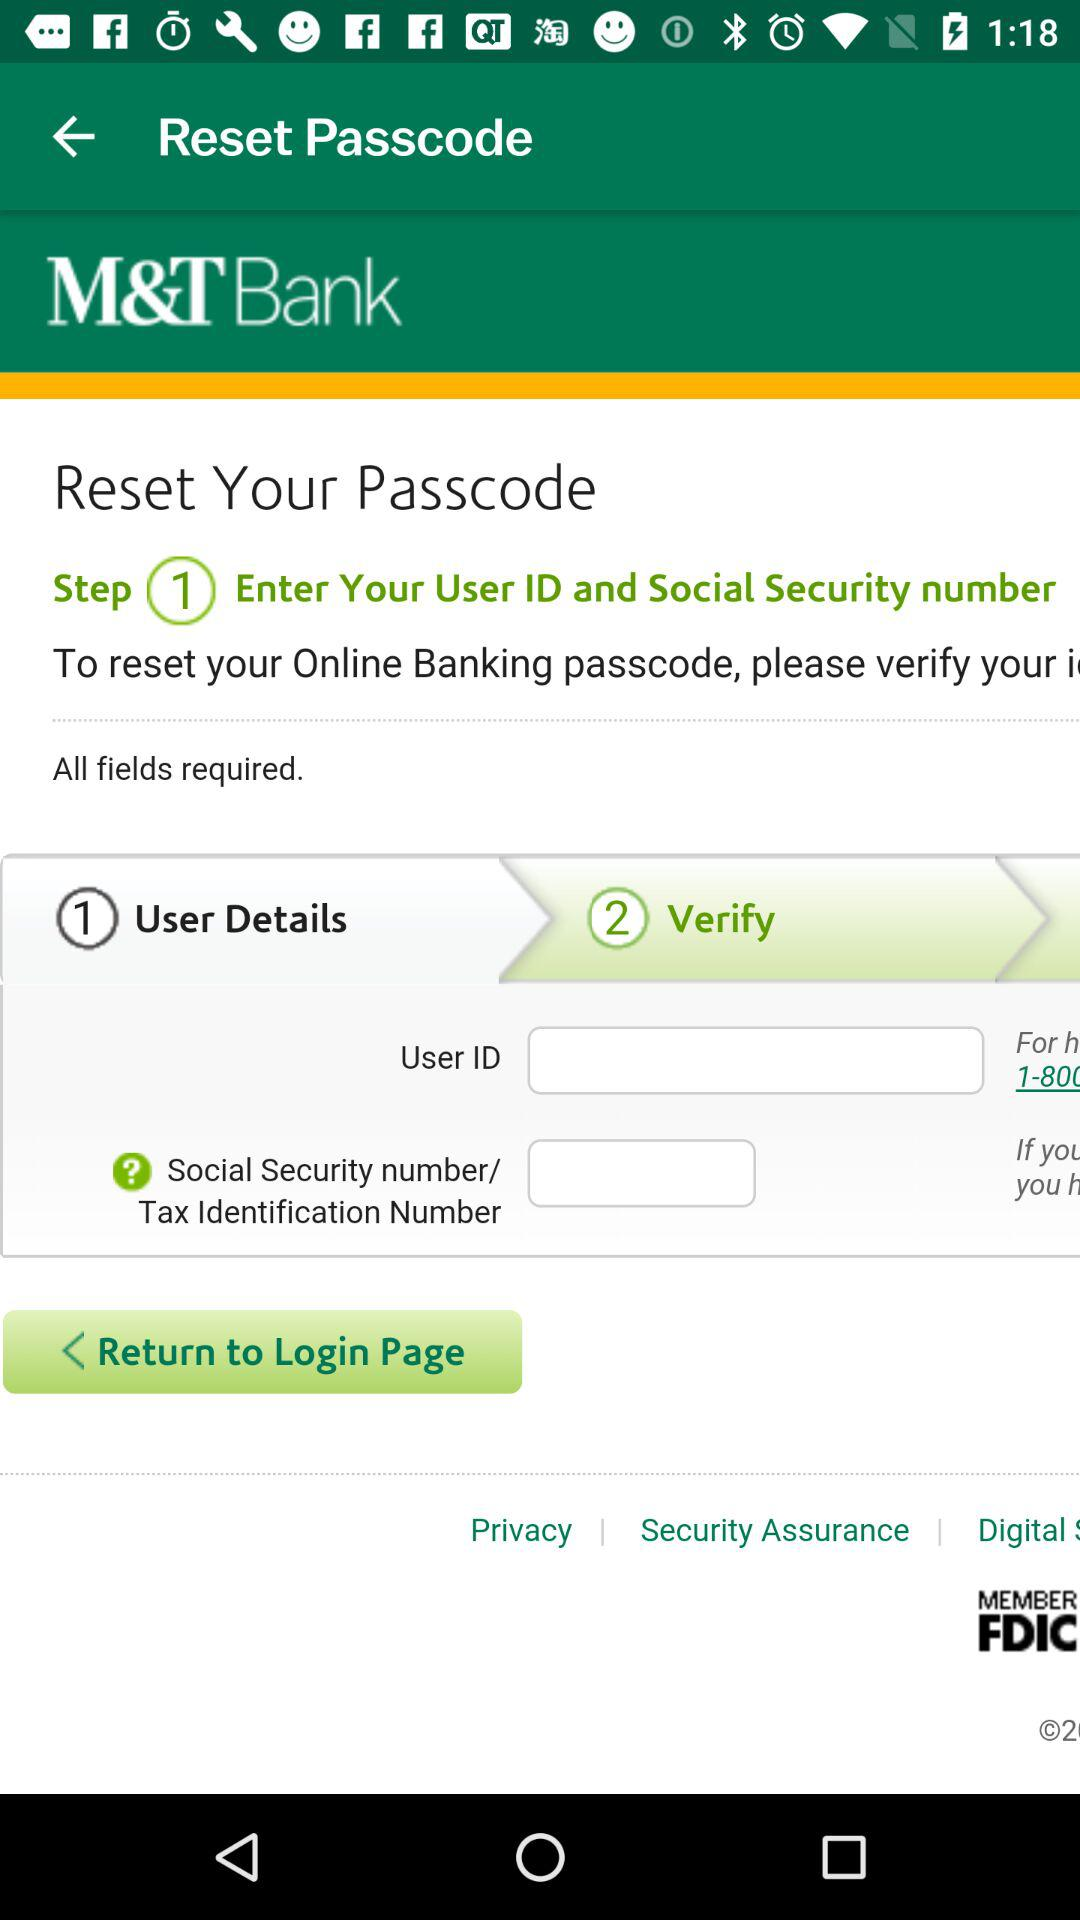What is the name of the application? The name of the application is "M&T Bank". 